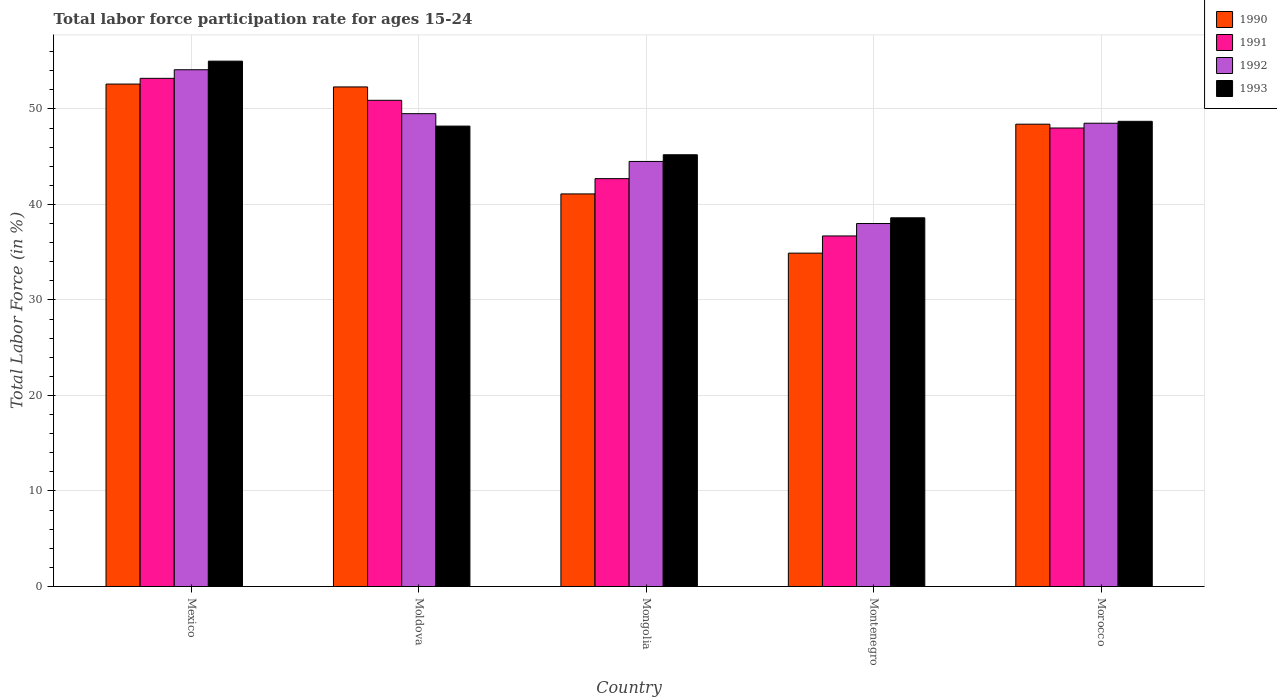How many different coloured bars are there?
Give a very brief answer. 4. How many groups of bars are there?
Your answer should be compact. 5. How many bars are there on the 1st tick from the right?
Your answer should be very brief. 4. What is the label of the 4th group of bars from the left?
Your response must be concise. Montenegro. What is the labor force participation rate in 1990 in Moldova?
Give a very brief answer. 52.3. Across all countries, what is the maximum labor force participation rate in 1992?
Ensure brevity in your answer.  54.1. Across all countries, what is the minimum labor force participation rate in 1991?
Give a very brief answer. 36.7. In which country was the labor force participation rate in 1993 minimum?
Keep it short and to the point. Montenegro. What is the total labor force participation rate in 1993 in the graph?
Give a very brief answer. 235.7. What is the difference between the labor force participation rate in 1992 in Mexico and that in Mongolia?
Offer a very short reply. 9.6. What is the difference between the labor force participation rate in 1990 in Moldova and the labor force participation rate in 1991 in Montenegro?
Your answer should be very brief. 15.6. What is the average labor force participation rate in 1992 per country?
Provide a succinct answer. 46.92. What is the difference between the labor force participation rate of/in 1991 and labor force participation rate of/in 1993 in Mexico?
Your answer should be compact. -1.8. What is the ratio of the labor force participation rate in 1992 in Moldova to that in Montenegro?
Provide a succinct answer. 1.3. Is the labor force participation rate in 1993 in Mexico less than that in Moldova?
Keep it short and to the point. No. What is the difference between the highest and the lowest labor force participation rate in 1990?
Offer a terse response. 17.7. In how many countries, is the labor force participation rate in 1993 greater than the average labor force participation rate in 1993 taken over all countries?
Your answer should be compact. 3. Is it the case that in every country, the sum of the labor force participation rate in 1993 and labor force participation rate in 1991 is greater than the sum of labor force participation rate in 1992 and labor force participation rate in 1990?
Keep it short and to the point. No. What does the 2nd bar from the left in Morocco represents?
Your answer should be compact. 1991. How many bars are there?
Make the answer very short. 20. What is the difference between two consecutive major ticks on the Y-axis?
Your response must be concise. 10. Are the values on the major ticks of Y-axis written in scientific E-notation?
Offer a terse response. No. Does the graph contain any zero values?
Offer a very short reply. No. How many legend labels are there?
Provide a short and direct response. 4. How are the legend labels stacked?
Keep it short and to the point. Vertical. What is the title of the graph?
Ensure brevity in your answer.  Total labor force participation rate for ages 15-24. Does "1991" appear as one of the legend labels in the graph?
Provide a succinct answer. Yes. What is the label or title of the Y-axis?
Give a very brief answer. Total Labor Force (in %). What is the Total Labor Force (in %) in 1990 in Mexico?
Ensure brevity in your answer.  52.6. What is the Total Labor Force (in %) in 1991 in Mexico?
Your answer should be compact. 53.2. What is the Total Labor Force (in %) in 1992 in Mexico?
Provide a succinct answer. 54.1. What is the Total Labor Force (in %) of 1993 in Mexico?
Offer a terse response. 55. What is the Total Labor Force (in %) in 1990 in Moldova?
Keep it short and to the point. 52.3. What is the Total Labor Force (in %) of 1991 in Moldova?
Your answer should be very brief. 50.9. What is the Total Labor Force (in %) in 1992 in Moldova?
Your answer should be compact. 49.5. What is the Total Labor Force (in %) of 1993 in Moldova?
Make the answer very short. 48.2. What is the Total Labor Force (in %) in 1990 in Mongolia?
Offer a very short reply. 41.1. What is the Total Labor Force (in %) of 1991 in Mongolia?
Make the answer very short. 42.7. What is the Total Labor Force (in %) in 1992 in Mongolia?
Your answer should be very brief. 44.5. What is the Total Labor Force (in %) in 1993 in Mongolia?
Provide a short and direct response. 45.2. What is the Total Labor Force (in %) of 1990 in Montenegro?
Keep it short and to the point. 34.9. What is the Total Labor Force (in %) of 1991 in Montenegro?
Offer a terse response. 36.7. What is the Total Labor Force (in %) of 1993 in Montenegro?
Offer a terse response. 38.6. What is the Total Labor Force (in %) in 1990 in Morocco?
Give a very brief answer. 48.4. What is the Total Labor Force (in %) of 1992 in Morocco?
Your response must be concise. 48.5. What is the Total Labor Force (in %) of 1993 in Morocco?
Your response must be concise. 48.7. Across all countries, what is the maximum Total Labor Force (in %) of 1990?
Make the answer very short. 52.6. Across all countries, what is the maximum Total Labor Force (in %) in 1991?
Make the answer very short. 53.2. Across all countries, what is the maximum Total Labor Force (in %) of 1992?
Make the answer very short. 54.1. Across all countries, what is the maximum Total Labor Force (in %) of 1993?
Keep it short and to the point. 55. Across all countries, what is the minimum Total Labor Force (in %) of 1990?
Provide a succinct answer. 34.9. Across all countries, what is the minimum Total Labor Force (in %) in 1991?
Your answer should be very brief. 36.7. Across all countries, what is the minimum Total Labor Force (in %) in 1993?
Offer a very short reply. 38.6. What is the total Total Labor Force (in %) in 1990 in the graph?
Your answer should be compact. 229.3. What is the total Total Labor Force (in %) in 1991 in the graph?
Your response must be concise. 231.5. What is the total Total Labor Force (in %) in 1992 in the graph?
Give a very brief answer. 234.6. What is the total Total Labor Force (in %) of 1993 in the graph?
Your answer should be very brief. 235.7. What is the difference between the Total Labor Force (in %) in 1991 in Mexico and that in Moldova?
Offer a terse response. 2.3. What is the difference between the Total Labor Force (in %) of 1993 in Mexico and that in Moldova?
Keep it short and to the point. 6.8. What is the difference between the Total Labor Force (in %) of 1990 in Mexico and that in Mongolia?
Provide a short and direct response. 11.5. What is the difference between the Total Labor Force (in %) of 1992 in Mexico and that in Mongolia?
Make the answer very short. 9.6. What is the difference between the Total Labor Force (in %) of 1993 in Mexico and that in Mongolia?
Offer a terse response. 9.8. What is the difference between the Total Labor Force (in %) in 1990 in Mexico and that in Montenegro?
Your response must be concise. 17.7. What is the difference between the Total Labor Force (in %) of 1991 in Mexico and that in Montenegro?
Offer a very short reply. 16.5. What is the difference between the Total Labor Force (in %) of 1990 in Mexico and that in Morocco?
Provide a succinct answer. 4.2. What is the difference between the Total Labor Force (in %) in 1991 in Mexico and that in Morocco?
Ensure brevity in your answer.  5.2. What is the difference between the Total Labor Force (in %) in 1993 in Mexico and that in Morocco?
Make the answer very short. 6.3. What is the difference between the Total Labor Force (in %) of 1992 in Moldova and that in Mongolia?
Offer a terse response. 5. What is the difference between the Total Labor Force (in %) in 1992 in Moldova and that in Montenegro?
Ensure brevity in your answer.  11.5. What is the difference between the Total Labor Force (in %) in 1990 in Moldova and that in Morocco?
Provide a succinct answer. 3.9. What is the difference between the Total Labor Force (in %) of 1991 in Moldova and that in Morocco?
Your response must be concise. 2.9. What is the difference between the Total Labor Force (in %) in 1992 in Moldova and that in Morocco?
Provide a succinct answer. 1. What is the difference between the Total Labor Force (in %) in 1990 in Mongolia and that in Montenegro?
Make the answer very short. 6.2. What is the difference between the Total Labor Force (in %) in 1991 in Mongolia and that in Montenegro?
Provide a succinct answer. 6. What is the difference between the Total Labor Force (in %) of 1993 in Mongolia and that in Montenegro?
Your answer should be very brief. 6.6. What is the difference between the Total Labor Force (in %) of 1992 in Mongolia and that in Morocco?
Offer a very short reply. -4. What is the difference between the Total Labor Force (in %) in 1993 in Mongolia and that in Morocco?
Your response must be concise. -3.5. What is the difference between the Total Labor Force (in %) in 1990 in Montenegro and that in Morocco?
Provide a short and direct response. -13.5. What is the difference between the Total Labor Force (in %) in 1991 in Montenegro and that in Morocco?
Provide a succinct answer. -11.3. What is the difference between the Total Labor Force (in %) of 1993 in Montenegro and that in Morocco?
Give a very brief answer. -10.1. What is the difference between the Total Labor Force (in %) in 1990 in Mexico and the Total Labor Force (in %) in 1991 in Moldova?
Your answer should be compact. 1.7. What is the difference between the Total Labor Force (in %) in 1991 in Mexico and the Total Labor Force (in %) in 1992 in Moldova?
Ensure brevity in your answer.  3.7. What is the difference between the Total Labor Force (in %) in 1992 in Mexico and the Total Labor Force (in %) in 1993 in Moldova?
Provide a succinct answer. 5.9. What is the difference between the Total Labor Force (in %) of 1990 in Mexico and the Total Labor Force (in %) of 1992 in Mongolia?
Keep it short and to the point. 8.1. What is the difference between the Total Labor Force (in %) of 1991 in Mexico and the Total Labor Force (in %) of 1992 in Mongolia?
Your answer should be very brief. 8.7. What is the difference between the Total Labor Force (in %) of 1990 in Mexico and the Total Labor Force (in %) of 1991 in Montenegro?
Your response must be concise. 15.9. What is the difference between the Total Labor Force (in %) in 1990 in Mexico and the Total Labor Force (in %) in 1992 in Montenegro?
Ensure brevity in your answer.  14.6. What is the difference between the Total Labor Force (in %) of 1990 in Mexico and the Total Labor Force (in %) of 1991 in Morocco?
Make the answer very short. 4.6. What is the difference between the Total Labor Force (in %) of 1991 in Mexico and the Total Labor Force (in %) of 1992 in Morocco?
Make the answer very short. 4.7. What is the difference between the Total Labor Force (in %) of 1990 in Moldova and the Total Labor Force (in %) of 1991 in Mongolia?
Your response must be concise. 9.6. What is the difference between the Total Labor Force (in %) of 1990 in Moldova and the Total Labor Force (in %) of 1992 in Mongolia?
Provide a short and direct response. 7.8. What is the difference between the Total Labor Force (in %) in 1990 in Moldova and the Total Labor Force (in %) in 1993 in Mongolia?
Your response must be concise. 7.1. What is the difference between the Total Labor Force (in %) of 1992 in Moldova and the Total Labor Force (in %) of 1993 in Mongolia?
Give a very brief answer. 4.3. What is the difference between the Total Labor Force (in %) of 1990 in Moldova and the Total Labor Force (in %) of 1992 in Montenegro?
Make the answer very short. 14.3. What is the difference between the Total Labor Force (in %) in 1991 in Moldova and the Total Labor Force (in %) in 1993 in Montenegro?
Your response must be concise. 12.3. What is the difference between the Total Labor Force (in %) of 1990 in Moldova and the Total Labor Force (in %) of 1991 in Morocco?
Your response must be concise. 4.3. What is the difference between the Total Labor Force (in %) of 1990 in Moldova and the Total Labor Force (in %) of 1992 in Morocco?
Your answer should be compact. 3.8. What is the difference between the Total Labor Force (in %) of 1990 in Moldova and the Total Labor Force (in %) of 1993 in Morocco?
Provide a short and direct response. 3.6. What is the difference between the Total Labor Force (in %) in 1992 in Moldova and the Total Labor Force (in %) in 1993 in Morocco?
Make the answer very short. 0.8. What is the difference between the Total Labor Force (in %) of 1990 in Mongolia and the Total Labor Force (in %) of 1991 in Montenegro?
Ensure brevity in your answer.  4.4. What is the difference between the Total Labor Force (in %) in 1990 in Mongolia and the Total Labor Force (in %) in 1993 in Montenegro?
Offer a very short reply. 2.5. What is the difference between the Total Labor Force (in %) in 1991 in Mongolia and the Total Labor Force (in %) in 1993 in Morocco?
Give a very brief answer. -6. What is the difference between the Total Labor Force (in %) in 1990 in Montenegro and the Total Labor Force (in %) in 1991 in Morocco?
Your response must be concise. -13.1. What is the difference between the Total Labor Force (in %) in 1990 in Montenegro and the Total Labor Force (in %) in 1993 in Morocco?
Your answer should be compact. -13.8. What is the difference between the Total Labor Force (in %) in 1992 in Montenegro and the Total Labor Force (in %) in 1993 in Morocco?
Provide a short and direct response. -10.7. What is the average Total Labor Force (in %) of 1990 per country?
Offer a terse response. 45.86. What is the average Total Labor Force (in %) in 1991 per country?
Give a very brief answer. 46.3. What is the average Total Labor Force (in %) of 1992 per country?
Give a very brief answer. 46.92. What is the average Total Labor Force (in %) of 1993 per country?
Provide a short and direct response. 47.14. What is the difference between the Total Labor Force (in %) in 1990 and Total Labor Force (in %) in 1993 in Mexico?
Offer a very short reply. -2.4. What is the difference between the Total Labor Force (in %) in 1992 and Total Labor Force (in %) in 1993 in Mexico?
Your answer should be compact. -0.9. What is the difference between the Total Labor Force (in %) in 1990 and Total Labor Force (in %) in 1991 in Moldova?
Offer a very short reply. 1.4. What is the difference between the Total Labor Force (in %) of 1990 and Total Labor Force (in %) of 1993 in Moldova?
Keep it short and to the point. 4.1. What is the difference between the Total Labor Force (in %) of 1990 and Total Labor Force (in %) of 1991 in Mongolia?
Provide a short and direct response. -1.6. What is the difference between the Total Labor Force (in %) of 1990 and Total Labor Force (in %) of 1993 in Mongolia?
Keep it short and to the point. -4.1. What is the difference between the Total Labor Force (in %) in 1991 and Total Labor Force (in %) in 1992 in Mongolia?
Make the answer very short. -1.8. What is the difference between the Total Labor Force (in %) of 1991 and Total Labor Force (in %) of 1993 in Mongolia?
Your answer should be compact. -2.5. What is the difference between the Total Labor Force (in %) of 1990 and Total Labor Force (in %) of 1993 in Montenegro?
Offer a very short reply. -3.7. What is the difference between the Total Labor Force (in %) in 1991 and Total Labor Force (in %) in 1992 in Montenegro?
Your response must be concise. -1.3. What is the difference between the Total Labor Force (in %) in 1990 and Total Labor Force (in %) in 1992 in Morocco?
Your answer should be very brief. -0.1. What is the difference between the Total Labor Force (in %) of 1991 and Total Labor Force (in %) of 1992 in Morocco?
Your answer should be very brief. -0.5. What is the difference between the Total Labor Force (in %) in 1991 and Total Labor Force (in %) in 1993 in Morocco?
Offer a terse response. -0.7. What is the difference between the Total Labor Force (in %) in 1992 and Total Labor Force (in %) in 1993 in Morocco?
Make the answer very short. -0.2. What is the ratio of the Total Labor Force (in %) of 1991 in Mexico to that in Moldova?
Ensure brevity in your answer.  1.05. What is the ratio of the Total Labor Force (in %) in 1992 in Mexico to that in Moldova?
Your answer should be compact. 1.09. What is the ratio of the Total Labor Force (in %) in 1993 in Mexico to that in Moldova?
Make the answer very short. 1.14. What is the ratio of the Total Labor Force (in %) of 1990 in Mexico to that in Mongolia?
Your response must be concise. 1.28. What is the ratio of the Total Labor Force (in %) of 1991 in Mexico to that in Mongolia?
Give a very brief answer. 1.25. What is the ratio of the Total Labor Force (in %) of 1992 in Mexico to that in Mongolia?
Give a very brief answer. 1.22. What is the ratio of the Total Labor Force (in %) of 1993 in Mexico to that in Mongolia?
Your answer should be very brief. 1.22. What is the ratio of the Total Labor Force (in %) of 1990 in Mexico to that in Montenegro?
Keep it short and to the point. 1.51. What is the ratio of the Total Labor Force (in %) of 1991 in Mexico to that in Montenegro?
Provide a short and direct response. 1.45. What is the ratio of the Total Labor Force (in %) of 1992 in Mexico to that in Montenegro?
Offer a terse response. 1.42. What is the ratio of the Total Labor Force (in %) in 1993 in Mexico to that in Montenegro?
Ensure brevity in your answer.  1.42. What is the ratio of the Total Labor Force (in %) in 1990 in Mexico to that in Morocco?
Your response must be concise. 1.09. What is the ratio of the Total Labor Force (in %) of 1991 in Mexico to that in Morocco?
Your answer should be compact. 1.11. What is the ratio of the Total Labor Force (in %) in 1992 in Mexico to that in Morocco?
Your answer should be compact. 1.12. What is the ratio of the Total Labor Force (in %) of 1993 in Mexico to that in Morocco?
Give a very brief answer. 1.13. What is the ratio of the Total Labor Force (in %) in 1990 in Moldova to that in Mongolia?
Your answer should be compact. 1.27. What is the ratio of the Total Labor Force (in %) of 1991 in Moldova to that in Mongolia?
Ensure brevity in your answer.  1.19. What is the ratio of the Total Labor Force (in %) of 1992 in Moldova to that in Mongolia?
Your answer should be compact. 1.11. What is the ratio of the Total Labor Force (in %) of 1993 in Moldova to that in Mongolia?
Your response must be concise. 1.07. What is the ratio of the Total Labor Force (in %) in 1990 in Moldova to that in Montenegro?
Your answer should be compact. 1.5. What is the ratio of the Total Labor Force (in %) in 1991 in Moldova to that in Montenegro?
Ensure brevity in your answer.  1.39. What is the ratio of the Total Labor Force (in %) of 1992 in Moldova to that in Montenegro?
Your response must be concise. 1.3. What is the ratio of the Total Labor Force (in %) of 1993 in Moldova to that in Montenegro?
Provide a short and direct response. 1.25. What is the ratio of the Total Labor Force (in %) of 1990 in Moldova to that in Morocco?
Provide a short and direct response. 1.08. What is the ratio of the Total Labor Force (in %) in 1991 in Moldova to that in Morocco?
Ensure brevity in your answer.  1.06. What is the ratio of the Total Labor Force (in %) in 1992 in Moldova to that in Morocco?
Keep it short and to the point. 1.02. What is the ratio of the Total Labor Force (in %) of 1990 in Mongolia to that in Montenegro?
Your answer should be compact. 1.18. What is the ratio of the Total Labor Force (in %) of 1991 in Mongolia to that in Montenegro?
Offer a terse response. 1.16. What is the ratio of the Total Labor Force (in %) in 1992 in Mongolia to that in Montenegro?
Keep it short and to the point. 1.17. What is the ratio of the Total Labor Force (in %) in 1993 in Mongolia to that in Montenegro?
Offer a terse response. 1.17. What is the ratio of the Total Labor Force (in %) in 1990 in Mongolia to that in Morocco?
Offer a very short reply. 0.85. What is the ratio of the Total Labor Force (in %) of 1991 in Mongolia to that in Morocco?
Provide a short and direct response. 0.89. What is the ratio of the Total Labor Force (in %) of 1992 in Mongolia to that in Morocco?
Offer a very short reply. 0.92. What is the ratio of the Total Labor Force (in %) in 1993 in Mongolia to that in Morocco?
Offer a terse response. 0.93. What is the ratio of the Total Labor Force (in %) in 1990 in Montenegro to that in Morocco?
Make the answer very short. 0.72. What is the ratio of the Total Labor Force (in %) of 1991 in Montenegro to that in Morocco?
Offer a terse response. 0.76. What is the ratio of the Total Labor Force (in %) in 1992 in Montenegro to that in Morocco?
Make the answer very short. 0.78. What is the ratio of the Total Labor Force (in %) of 1993 in Montenegro to that in Morocco?
Keep it short and to the point. 0.79. What is the difference between the highest and the second highest Total Labor Force (in %) of 1990?
Ensure brevity in your answer.  0.3. What is the difference between the highest and the second highest Total Labor Force (in %) of 1991?
Give a very brief answer. 2.3. What is the difference between the highest and the second highest Total Labor Force (in %) of 1992?
Ensure brevity in your answer.  4.6. What is the difference between the highest and the lowest Total Labor Force (in %) in 1990?
Your response must be concise. 17.7. What is the difference between the highest and the lowest Total Labor Force (in %) of 1992?
Your answer should be very brief. 16.1. What is the difference between the highest and the lowest Total Labor Force (in %) in 1993?
Offer a very short reply. 16.4. 